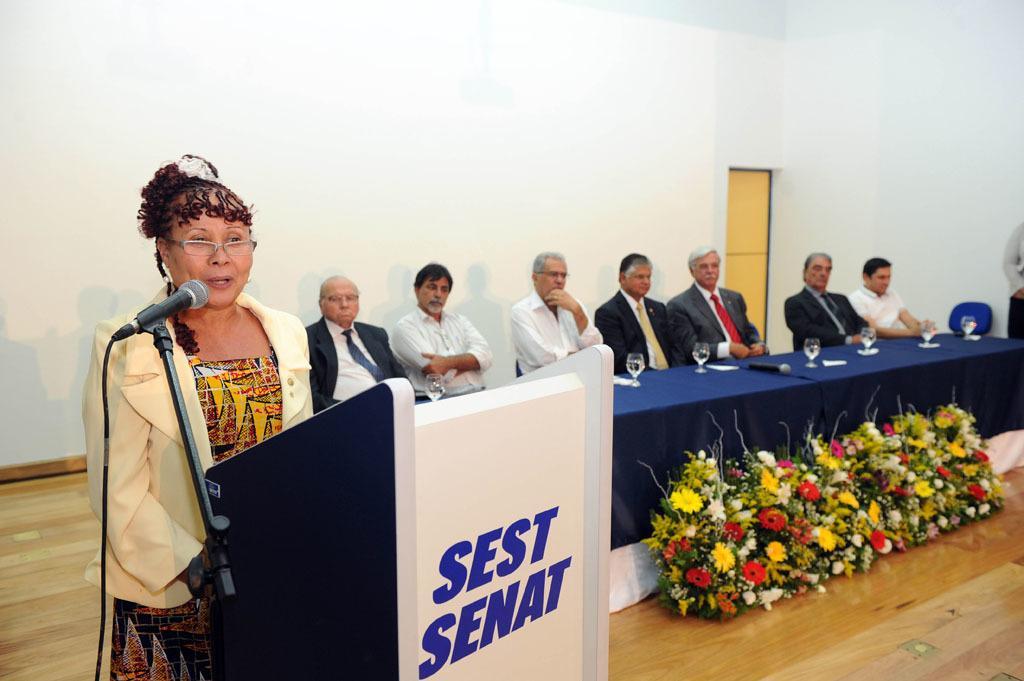Describe this image in one or two sentences. This image is taken indoors. in the background there is a wall with a door. At the bottom of the image there is a floor. On the left side of the image there is a podium with a text on it and there is a mic. A woman is standing and talking. On the right side of the image there is a table with a tablecloth, a mic and a few glasses of water on it. There are a few bouquets with flowers on the floor. A few men are sitting on the chairs and a man is standing on the floor. 